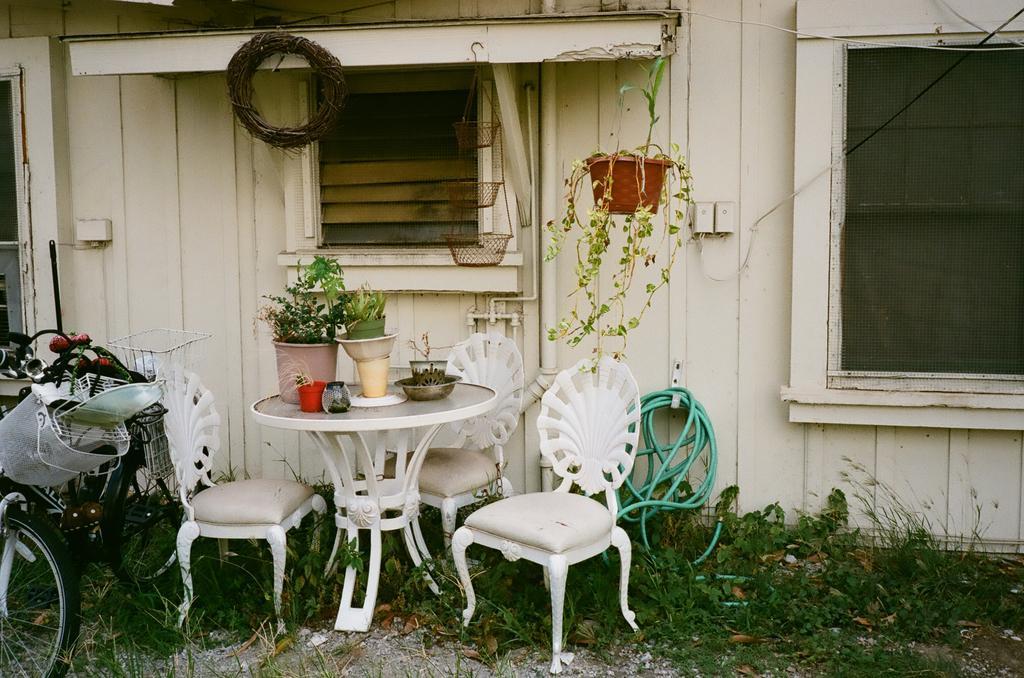Can you describe this image briefly? This picture shows few plants on the table and three chairs and a water pipe and a plant hanging and we see a bicycle 